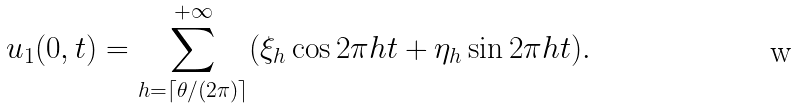Convert formula to latex. <formula><loc_0><loc_0><loc_500><loc_500>u _ { 1 } ( 0 , t ) = \sum _ { h = \lceil \theta / ( 2 \pi ) \rceil } ^ { + \infty } ( \xi _ { h } \cos 2 \pi h t + \eta _ { h } \sin 2 \pi h t ) .</formula> 